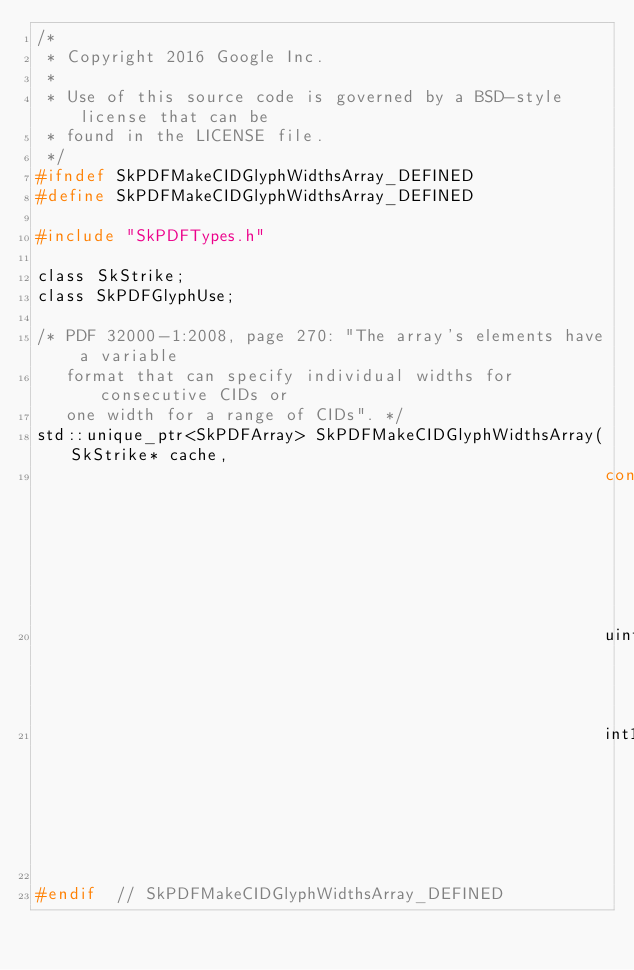<code> <loc_0><loc_0><loc_500><loc_500><_C_>/*
 * Copyright 2016 Google Inc.
 *
 * Use of this source code is governed by a BSD-style license that can be
 * found in the LICENSE file.
 */
#ifndef SkPDFMakeCIDGlyphWidthsArray_DEFINED
#define SkPDFMakeCIDGlyphWidthsArray_DEFINED

#include "SkPDFTypes.h"

class SkStrike;
class SkPDFGlyphUse;

/* PDF 32000-1:2008, page 270: "The array's elements have a variable
   format that can specify individual widths for consecutive CIDs or
   one width for a range of CIDs". */
std::unique_ptr<SkPDFArray> SkPDFMakeCIDGlyphWidthsArray(SkStrike* cache,
                                                         const SkPDFGlyphUse* subset,
                                                         uint16_t emSize,
                                                         int16_t* defaultWidth);

#endif  // SkPDFMakeCIDGlyphWidthsArray_DEFINED
</code> 